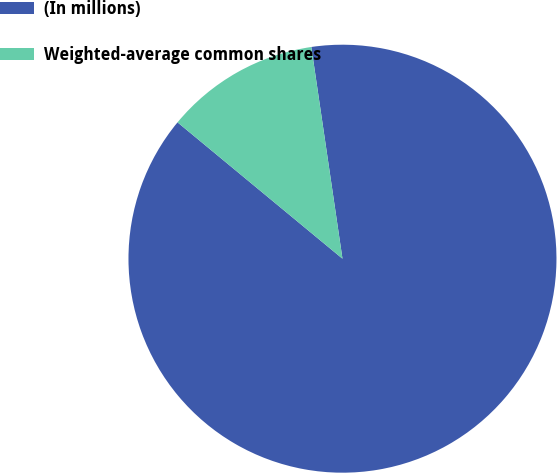Convert chart to OTSL. <chart><loc_0><loc_0><loc_500><loc_500><pie_chart><fcel>(In millions)<fcel>Weighted-average common shares<nl><fcel>88.32%<fcel>11.68%<nl></chart> 